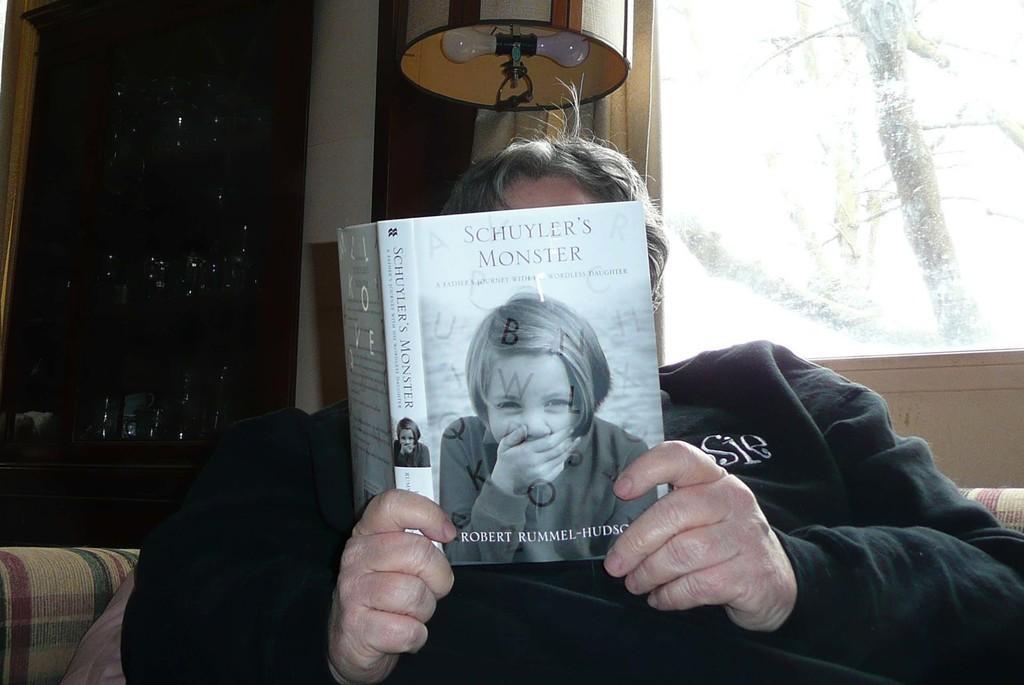Describe this image in one or two sentences. In the center of the image we can see a person holding the book and on the book we can see the human image and also the text. In the background we can see the glasses. We can also see the glass window and behind the glass window we can see the trees. 